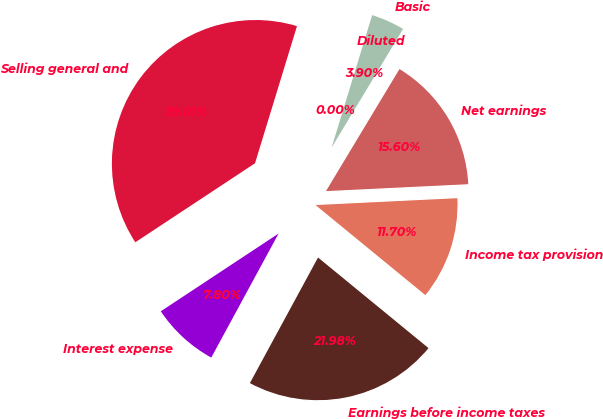Convert chart to OTSL. <chart><loc_0><loc_0><loc_500><loc_500><pie_chart><fcel>Selling general and<fcel>Interest expense<fcel>Earnings before income taxes<fcel>Income tax provision<fcel>Net earnings<fcel>Basic<fcel>Diluted<nl><fcel>39.01%<fcel>7.8%<fcel>21.98%<fcel>11.7%<fcel>15.6%<fcel>3.9%<fcel>0.0%<nl></chart> 